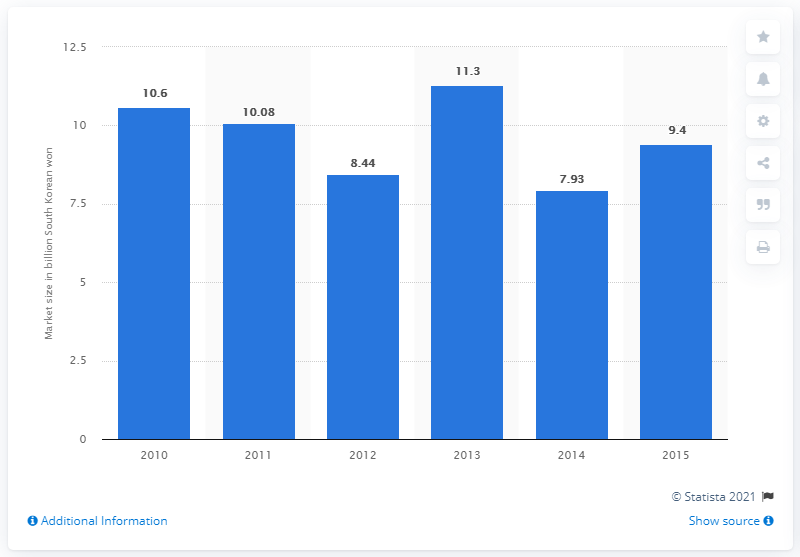Give some essential details in this illustration. In 2015, the market value of hard contact lenses in South Korea was approximately 9.4. In 2010, the value of the hard contact lens market in South Korea was 7.93. 